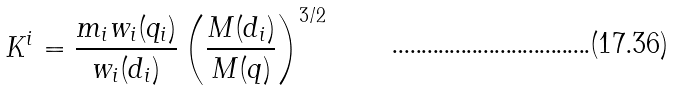<formula> <loc_0><loc_0><loc_500><loc_500>K ^ { i } = \frac { m _ { i } w _ { i } ( { q } _ { i } ) } { w _ { i } ( { d } _ { i } ) } \left ( \frac { M ( { d } _ { i } ) } { M ( { q } ) } \right ) ^ { 3 / 2 }</formula> 